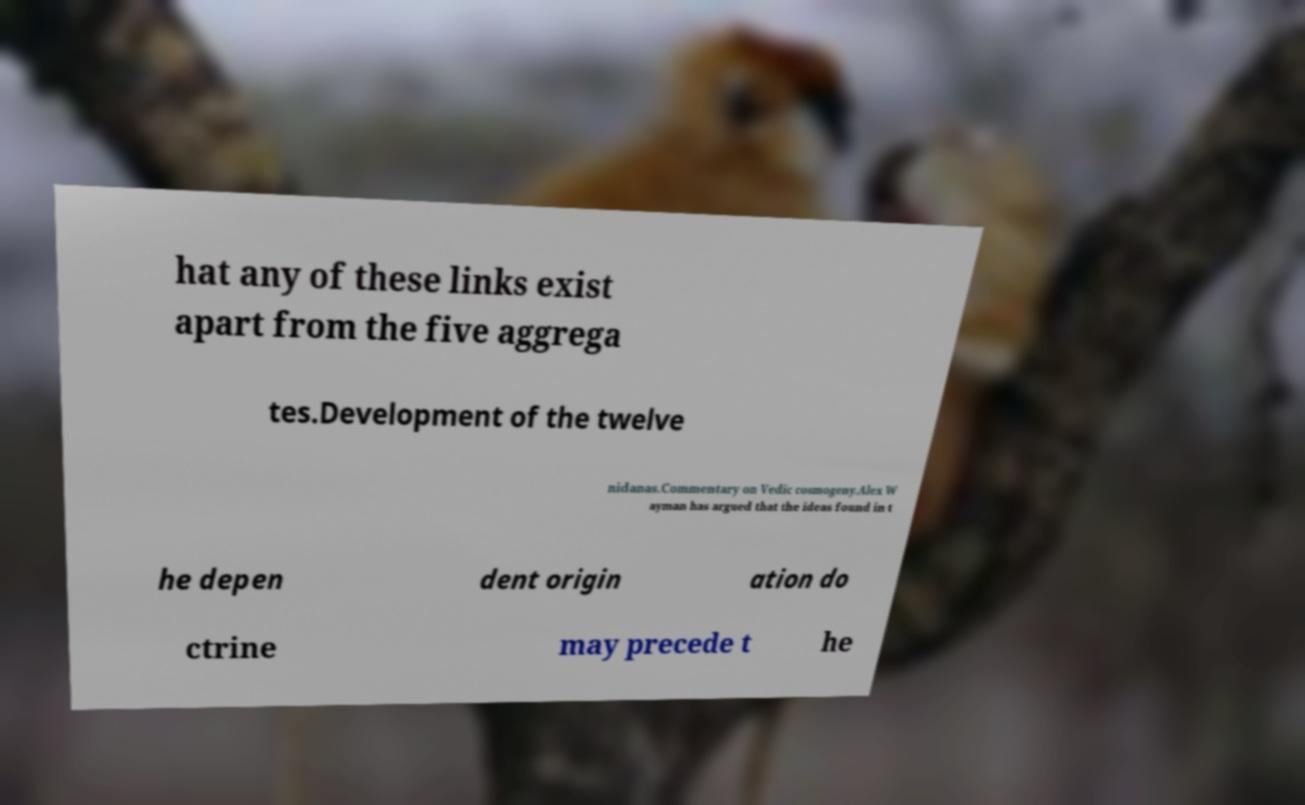Please read and relay the text visible in this image. What does it say? hat any of these links exist apart from the five aggrega tes.Development of the twelve nidanas.Commentary on Vedic cosmogeny.Alex W ayman has argued that the ideas found in t he depen dent origin ation do ctrine may precede t he 